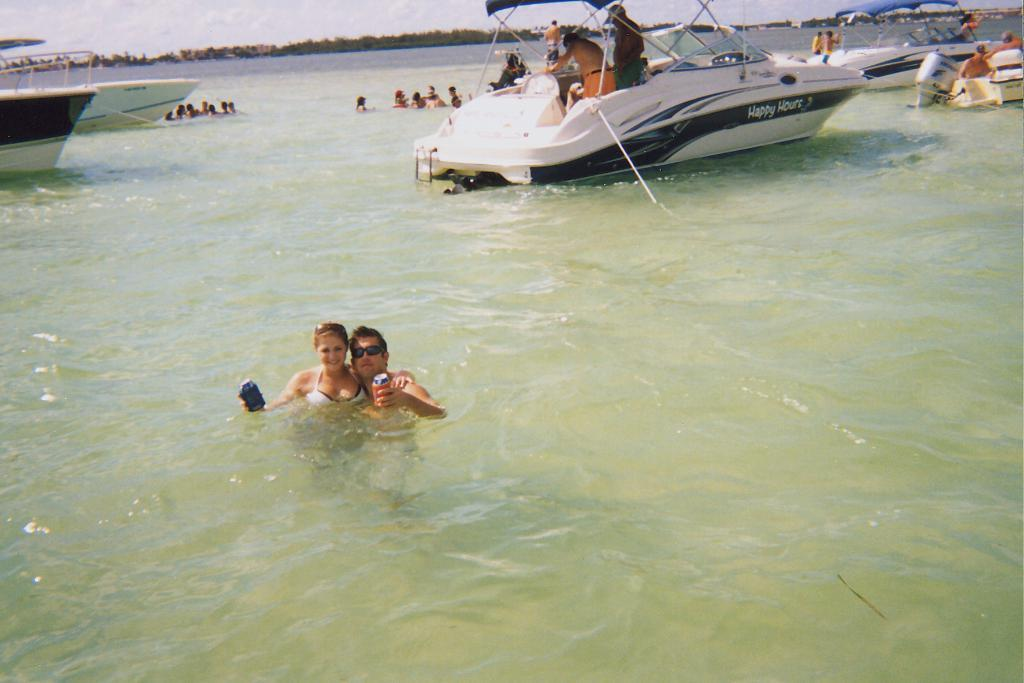Who are the people in the image? There is a man and a woman in the image. What are they doing in the image? They are in a swimming pool. What else can be seen in the image besides the man and woman? There are yachts and other people in the image. Where are the man and woman located in the image? They are on the left side of the image. Where are the yachts and other people located in the image? They are at the top side of the image. What is the brass form used for in the image? There is no brass form present in the image. 